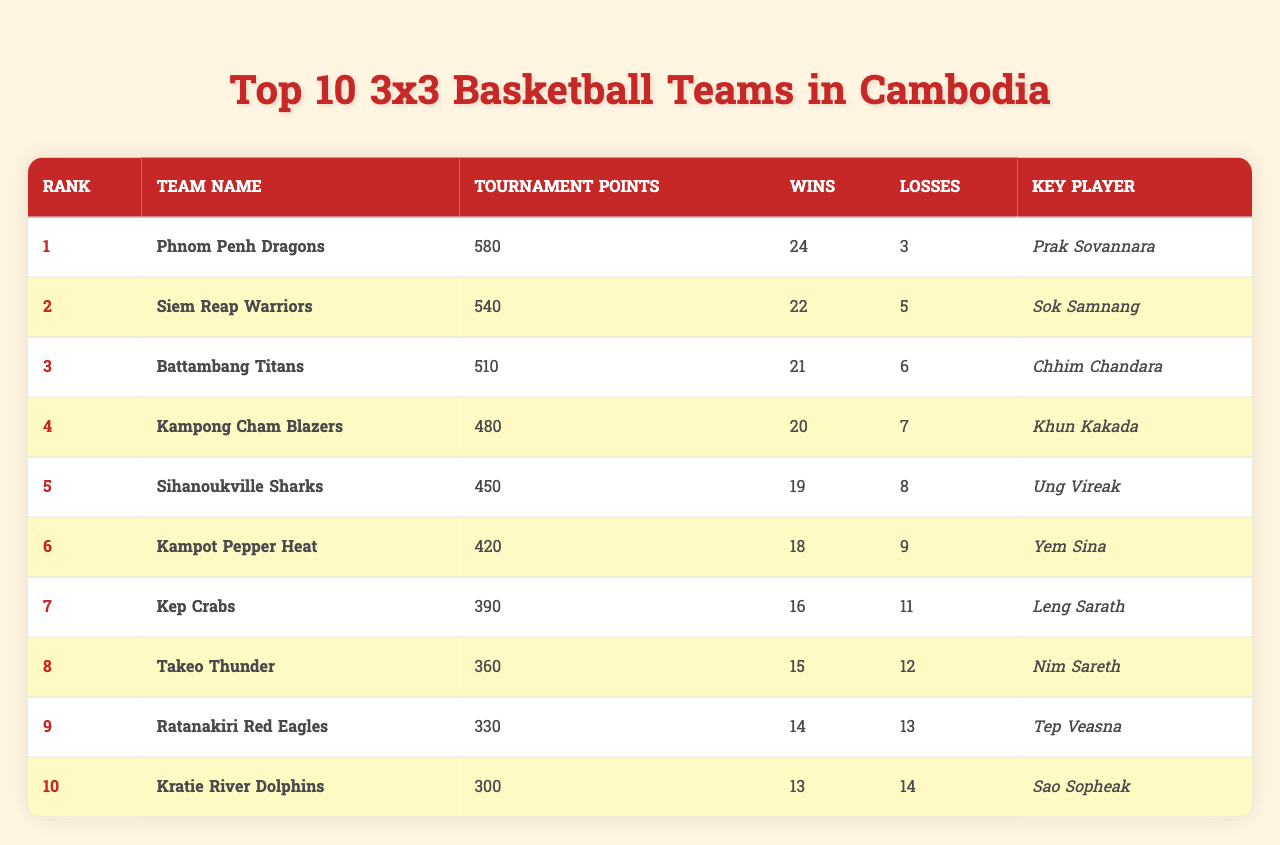What is the rank of the Phnom Penh Dragons? The table lists the Phnom Penh Dragons as being in the first position under the "Rank" column.
Answer: 1 How many tournament points does the Siem Reap Warriors have? The "Tournament Points" column shows that the Siem Reap Warriors have 540 points.
Answer: 540 Who is the key player for the Battambang Titans? By looking at the "Key Player" column, the key player for the Battambang Titans is identified as Chhim Chandara.
Answer: Chhim Chandara Which team has the highest number of wins? The "Wins" column indicates that the Phnom Penh Dragons lead with 24 wins, more than any other team.
Answer: Phnom Penh Dragons What is the total number of losses for the top three teams combined? The total losses for the top three teams (Phnom Penh Dragons: 3, Siem Reap Warriors: 5, Battambang Titans: 6) is calculated as 3 + 5 + 6 = 14.
Answer: 14 Is it true that the Kampot Pepper Heat has more wins than losses? The Kampot Pepper Heat has 18 wins and 9 losses, which indicates more wins than losses, making the statement true.
Answer: Yes Which team has the lowest tournament points among the top 10? The team with the lowest tournament points is identified from the table as the Kratie River Dolphins, with 300 points.
Answer: Kratie River Dolphins What is the average number of wins for the top 10 teams? To find the average, sum the wins (24 + 22 + 21 + 20 + 19 + 18 + 16 + 15 + 14 + 13 = 202) and divide by the number of teams (10), giving an average of 20.2 wins.
Answer: 20.2 How many more tournament points does the Kep Crabs have compared to the Ratanakiri Red Eagles? The Kep Crabs have 390 points, while the Ratanakiri Red Eagles have 330 points, resulting in a difference of 390 - 330 = 60 points.
Answer: 60 Which team is the second-ranked team, and what is its key player's name? Looking at the table, the second-ranked team is the Siem Reap Warriors, and its key player is Sok Samnang.
Answer: Siem Reap Warriors, Sok Samnang 